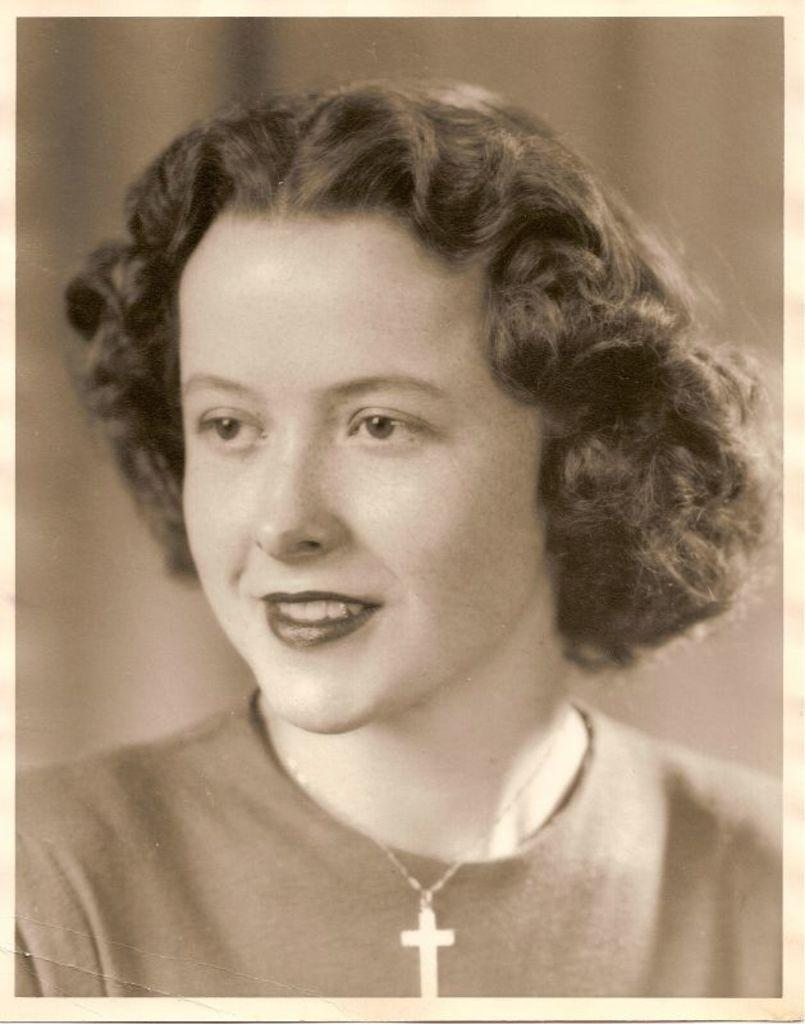What is the main subject in the foreground of the image? There is a woman in the foreground of the image. Can you describe the woman's hairstyle? The woman has short hair. What type of clothing is the woman wearing? The woman is wearing a T-shirt. What accessory is the woman wearing around her neck? The woman is wearing a cross symbol locket. What condition is the trick story in the image? There is no trick story present in the image. 